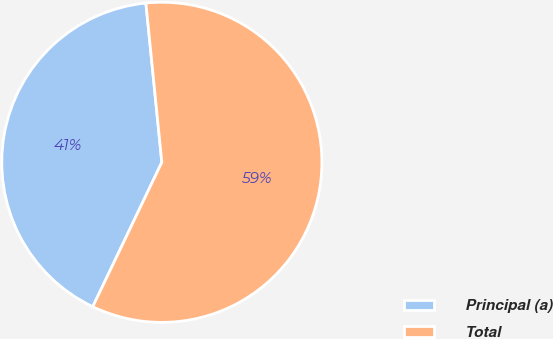Convert chart to OTSL. <chart><loc_0><loc_0><loc_500><loc_500><pie_chart><fcel>Principal (a)<fcel>Total<nl><fcel>41.31%<fcel>58.69%<nl></chart> 